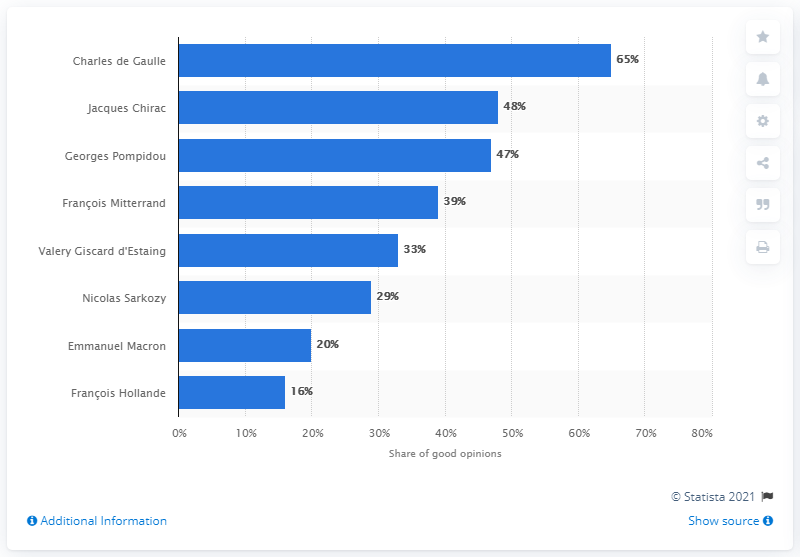Outline some significant characteristics in this image. Sixty-five percent of respondents indicated that they held a favorable view of Charles de Gaulle. 